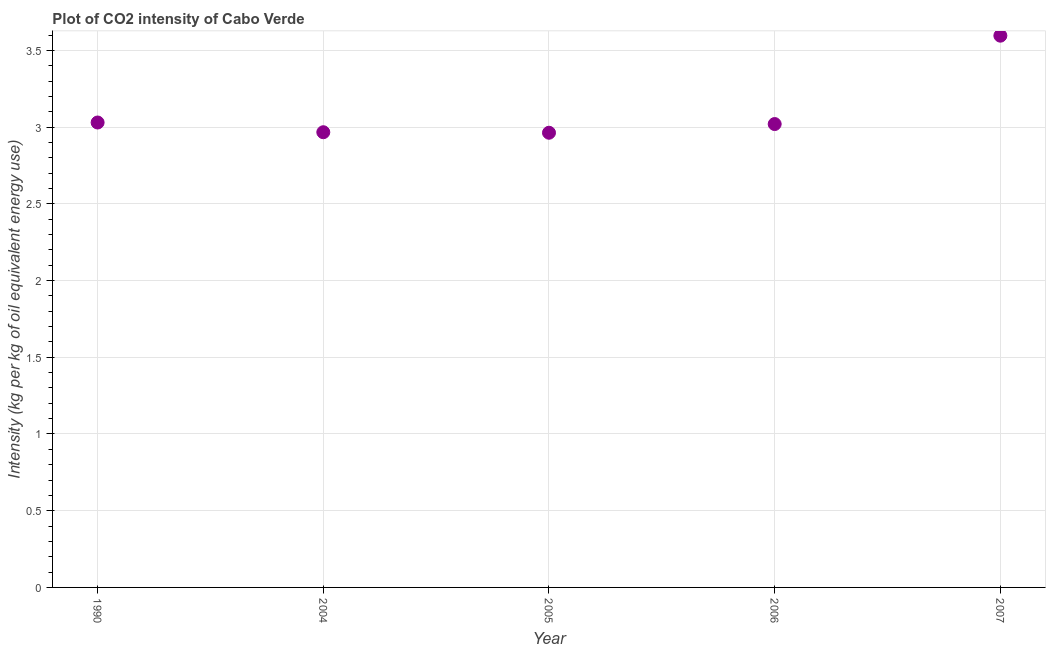What is the co2 intensity in 2005?
Offer a very short reply. 2.96. Across all years, what is the maximum co2 intensity?
Offer a terse response. 3.6. Across all years, what is the minimum co2 intensity?
Your answer should be compact. 2.96. In which year was the co2 intensity maximum?
Your response must be concise. 2007. In which year was the co2 intensity minimum?
Your response must be concise. 2005. What is the sum of the co2 intensity?
Your answer should be compact. 15.58. What is the difference between the co2 intensity in 2005 and 2007?
Offer a terse response. -0.63. What is the average co2 intensity per year?
Provide a succinct answer. 3.12. What is the median co2 intensity?
Give a very brief answer. 3.02. In how many years, is the co2 intensity greater than 1.3 kg?
Your answer should be very brief. 5. What is the ratio of the co2 intensity in 2005 to that in 2006?
Keep it short and to the point. 0.98. Is the co2 intensity in 2005 less than that in 2007?
Offer a very short reply. Yes. Is the difference between the co2 intensity in 1990 and 2007 greater than the difference between any two years?
Make the answer very short. No. What is the difference between the highest and the second highest co2 intensity?
Ensure brevity in your answer.  0.57. Is the sum of the co2 intensity in 2005 and 2007 greater than the maximum co2 intensity across all years?
Your response must be concise. Yes. What is the difference between the highest and the lowest co2 intensity?
Your answer should be compact. 0.63. Does the co2 intensity monotonically increase over the years?
Make the answer very short. No. How many dotlines are there?
Provide a short and direct response. 1. How many years are there in the graph?
Provide a short and direct response. 5. Are the values on the major ticks of Y-axis written in scientific E-notation?
Your answer should be very brief. No. Does the graph contain any zero values?
Provide a succinct answer. No. What is the title of the graph?
Your answer should be compact. Plot of CO2 intensity of Cabo Verde. What is the label or title of the Y-axis?
Ensure brevity in your answer.  Intensity (kg per kg of oil equivalent energy use). What is the Intensity (kg per kg of oil equivalent energy use) in 1990?
Give a very brief answer. 3.03. What is the Intensity (kg per kg of oil equivalent energy use) in 2004?
Keep it short and to the point. 2.97. What is the Intensity (kg per kg of oil equivalent energy use) in 2005?
Provide a short and direct response. 2.96. What is the Intensity (kg per kg of oil equivalent energy use) in 2006?
Offer a very short reply. 3.02. What is the Intensity (kg per kg of oil equivalent energy use) in 2007?
Offer a very short reply. 3.6. What is the difference between the Intensity (kg per kg of oil equivalent energy use) in 1990 and 2004?
Your answer should be very brief. 0.06. What is the difference between the Intensity (kg per kg of oil equivalent energy use) in 1990 and 2005?
Make the answer very short. 0.07. What is the difference between the Intensity (kg per kg of oil equivalent energy use) in 1990 and 2006?
Your answer should be very brief. 0.01. What is the difference between the Intensity (kg per kg of oil equivalent energy use) in 1990 and 2007?
Offer a very short reply. -0.57. What is the difference between the Intensity (kg per kg of oil equivalent energy use) in 2004 and 2005?
Offer a terse response. 0. What is the difference between the Intensity (kg per kg of oil equivalent energy use) in 2004 and 2006?
Your answer should be compact. -0.05. What is the difference between the Intensity (kg per kg of oil equivalent energy use) in 2004 and 2007?
Your answer should be very brief. -0.63. What is the difference between the Intensity (kg per kg of oil equivalent energy use) in 2005 and 2006?
Offer a very short reply. -0.06. What is the difference between the Intensity (kg per kg of oil equivalent energy use) in 2005 and 2007?
Ensure brevity in your answer.  -0.63. What is the difference between the Intensity (kg per kg of oil equivalent energy use) in 2006 and 2007?
Give a very brief answer. -0.58. What is the ratio of the Intensity (kg per kg of oil equivalent energy use) in 1990 to that in 2004?
Ensure brevity in your answer.  1.02. What is the ratio of the Intensity (kg per kg of oil equivalent energy use) in 1990 to that in 2005?
Ensure brevity in your answer.  1.02. What is the ratio of the Intensity (kg per kg of oil equivalent energy use) in 1990 to that in 2006?
Your answer should be very brief. 1. What is the ratio of the Intensity (kg per kg of oil equivalent energy use) in 1990 to that in 2007?
Your response must be concise. 0.84. What is the ratio of the Intensity (kg per kg of oil equivalent energy use) in 2004 to that in 2005?
Give a very brief answer. 1. What is the ratio of the Intensity (kg per kg of oil equivalent energy use) in 2004 to that in 2006?
Provide a short and direct response. 0.98. What is the ratio of the Intensity (kg per kg of oil equivalent energy use) in 2004 to that in 2007?
Make the answer very short. 0.82. What is the ratio of the Intensity (kg per kg of oil equivalent energy use) in 2005 to that in 2006?
Keep it short and to the point. 0.98. What is the ratio of the Intensity (kg per kg of oil equivalent energy use) in 2005 to that in 2007?
Provide a succinct answer. 0.82. What is the ratio of the Intensity (kg per kg of oil equivalent energy use) in 2006 to that in 2007?
Your answer should be compact. 0.84. 